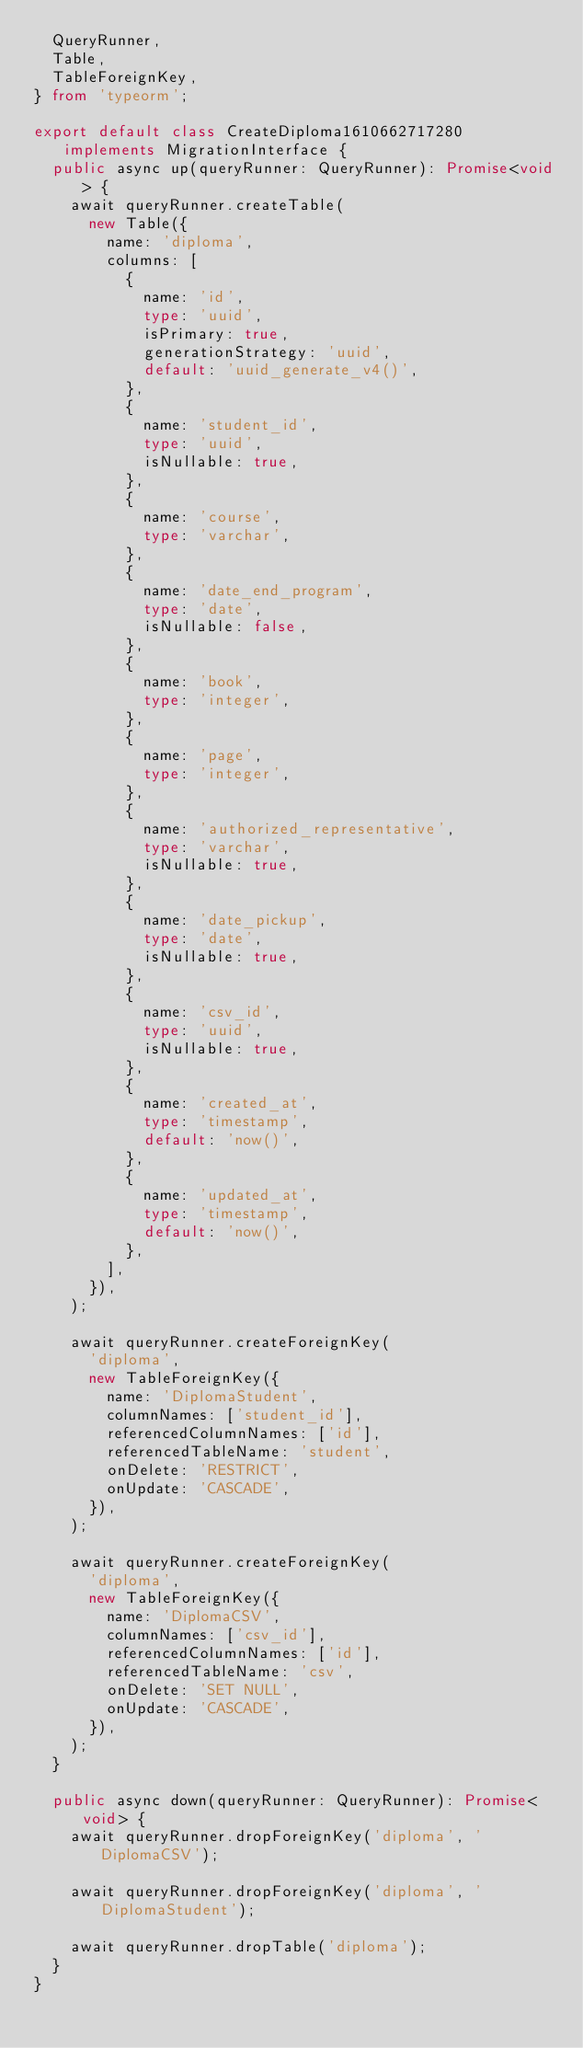<code> <loc_0><loc_0><loc_500><loc_500><_TypeScript_>  QueryRunner,
  Table,
  TableForeignKey,
} from 'typeorm';

export default class CreateDiploma1610662717280 implements MigrationInterface {
  public async up(queryRunner: QueryRunner): Promise<void> {
    await queryRunner.createTable(
      new Table({
        name: 'diploma',
        columns: [
          {
            name: 'id',
            type: 'uuid',
            isPrimary: true,
            generationStrategy: 'uuid',
            default: 'uuid_generate_v4()',
          },
          {
            name: 'student_id',
            type: 'uuid',
            isNullable: true,
          },
          {
            name: 'course',
            type: 'varchar',
          },
          {
            name: 'date_end_program',
            type: 'date',
            isNullable: false,
          },
          {
            name: 'book',
            type: 'integer',
          },
          {
            name: 'page',
            type: 'integer',
          },
          {
            name: 'authorized_representative',
            type: 'varchar',
            isNullable: true,
          },
          {
            name: 'date_pickup',
            type: 'date',
            isNullable: true,
          },
          {
            name: 'csv_id',
            type: 'uuid',
            isNullable: true,
          },
          {
            name: 'created_at',
            type: 'timestamp',
            default: 'now()',
          },
          {
            name: 'updated_at',
            type: 'timestamp',
            default: 'now()',
          },
        ],
      }),
    );

    await queryRunner.createForeignKey(
      'diploma',
      new TableForeignKey({
        name: 'DiplomaStudent',
        columnNames: ['student_id'],
        referencedColumnNames: ['id'],
        referencedTableName: 'student',
        onDelete: 'RESTRICT',
        onUpdate: 'CASCADE',
      }),
    );

    await queryRunner.createForeignKey(
      'diploma',
      new TableForeignKey({
        name: 'DiplomaCSV',
        columnNames: ['csv_id'],
        referencedColumnNames: ['id'],
        referencedTableName: 'csv',
        onDelete: 'SET NULL',
        onUpdate: 'CASCADE',
      }),
    );
  }

  public async down(queryRunner: QueryRunner): Promise<void> {
    await queryRunner.dropForeignKey('diploma', 'DiplomaCSV');

    await queryRunner.dropForeignKey('diploma', 'DiplomaStudent');

    await queryRunner.dropTable('diploma');
  }
}
</code> 